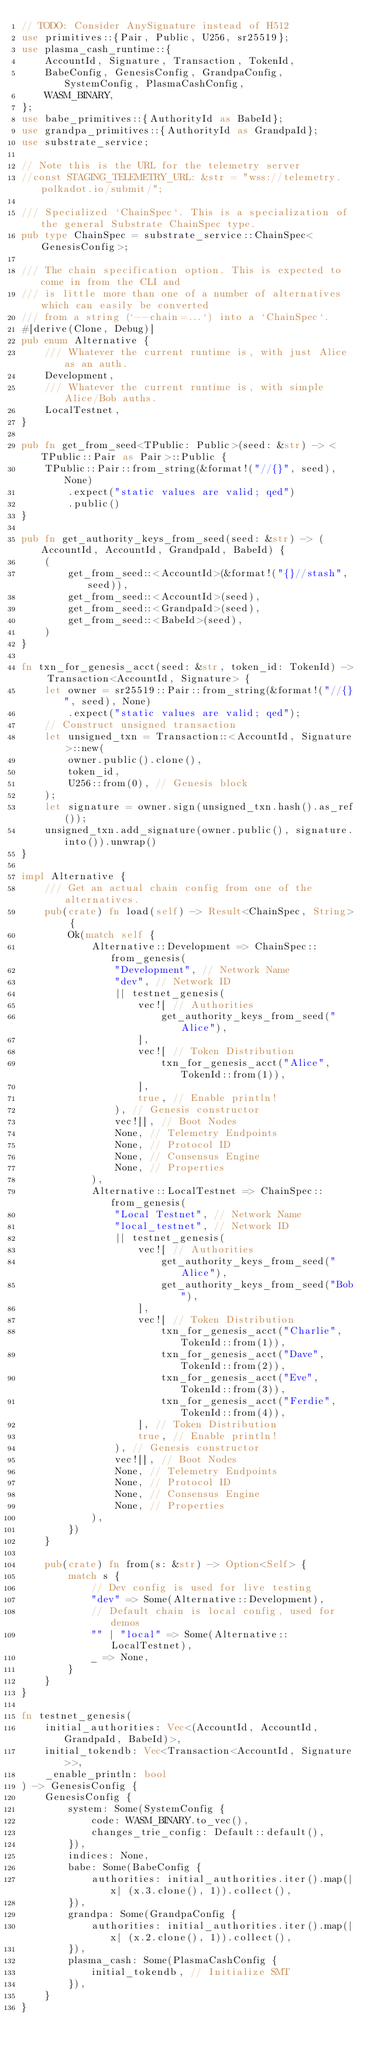Convert code to text. <code><loc_0><loc_0><loc_500><loc_500><_Rust_>// TODO: Consider AnySignature instead of H512
use primitives::{Pair, Public, U256, sr25519};
use plasma_cash_runtime::{
    AccountId, Signature, Transaction, TokenId,
    BabeConfig, GenesisConfig, GrandpaConfig, SystemConfig, PlasmaCashConfig,
    WASM_BINARY,
};
use babe_primitives::{AuthorityId as BabeId};
use grandpa_primitives::{AuthorityId as GrandpaId};
use substrate_service;

// Note this is the URL for the telemetry server
//const STAGING_TELEMETRY_URL: &str = "wss://telemetry.polkadot.io/submit/";

/// Specialized `ChainSpec`. This is a specialization of the general Substrate ChainSpec type.
pub type ChainSpec = substrate_service::ChainSpec<GenesisConfig>;

/// The chain specification option. This is expected to come in from the CLI and
/// is little more than one of a number of alternatives which can easily be converted
/// from a string (`--chain=...`) into a `ChainSpec`.
#[derive(Clone, Debug)]
pub enum Alternative {
    /// Whatever the current runtime is, with just Alice as an auth.
    Development,
    /// Whatever the current runtime is, with simple Alice/Bob auths.
    LocalTestnet,
}

pub fn get_from_seed<TPublic: Public>(seed: &str) -> <TPublic::Pair as Pair>::Public {
    TPublic::Pair::from_string(&format!("//{}", seed), None)
        .expect("static values are valid; qed")
        .public()
}

pub fn get_authority_keys_from_seed(seed: &str) -> (AccountId, AccountId, GrandpaId, BabeId) {
    (
        get_from_seed::<AccountId>(&format!("{}//stash", seed)),
        get_from_seed::<AccountId>(seed),
        get_from_seed::<GrandpaId>(seed),
        get_from_seed::<BabeId>(seed),
    )
}

fn txn_for_genesis_acct(seed: &str, token_id: TokenId) -> Transaction<AccountId, Signature> {
    let owner = sr25519::Pair::from_string(&format!("//{}", seed), None)
        .expect("static values are valid; qed");
    // Construct unsigned transaction
    let unsigned_txn = Transaction::<AccountId, Signature>::new(
        owner.public().clone(),
        token_id,
        U256::from(0), // Genesis block
    );
    let signature = owner.sign(unsigned_txn.hash().as_ref());
    unsigned_txn.add_signature(owner.public(), signature.into()).unwrap()
}

impl Alternative {
    /// Get an actual chain config from one of the alternatives.
    pub(crate) fn load(self) -> Result<ChainSpec, String> {
        Ok(match self {
            Alternative::Development => ChainSpec::from_genesis(
                "Development", // Network Name
                "dev", // Network ID
                || testnet_genesis(
                    vec![ // Authorities
                        get_authority_keys_from_seed("Alice"),
                    ],
                    vec![ // Token Distribution
                        txn_for_genesis_acct("Alice", TokenId::from(1)),
                    ],
                    true, // Enable println!
                ), // Genesis constructor
                vec![], // Boot Nodes
                None, // Telemetry Endpoints
                None, // Protocol ID
                None, // Consensus Engine
                None, // Properties
            ),
            Alternative::LocalTestnet => ChainSpec::from_genesis(
                "Local Testnet", // Network Name
                "local_testnet", // Network ID
                || testnet_genesis(
                    vec![ // Authorities
                        get_authority_keys_from_seed("Alice"),
                        get_authority_keys_from_seed("Bob"),
                    ],
                    vec![ // Token Distribution
                        txn_for_genesis_acct("Charlie", TokenId::from(1)),
                        txn_for_genesis_acct("Dave",    TokenId::from(2)),
                        txn_for_genesis_acct("Eve",     TokenId::from(3)),
                        txn_for_genesis_acct("Ferdie",  TokenId::from(4)),
                    ], // Token Distribution
                    true, // Enable println!
                ), // Genesis constructor
                vec![], // Boot Nodes
                None, // Telemetry Endpoints
                None, // Protocol ID
                None, // Consensus Engine
                None, // Properties
            ),
        })
    }

    pub(crate) fn from(s: &str) -> Option<Self> {
        match s {
            // Dev config is used for live testing
            "dev" => Some(Alternative::Development),
            // Default chain is local config, used for demos
            "" | "local" => Some(Alternative::LocalTestnet),
            _ => None,
        }
    }
}

fn testnet_genesis(
    initial_authorities: Vec<(AccountId, AccountId, GrandpaId, BabeId)>,
    initial_tokendb: Vec<Transaction<AccountId, Signature>>,
    _enable_println: bool
) -> GenesisConfig {
    GenesisConfig {
        system: Some(SystemConfig {
            code: WASM_BINARY.to_vec(),
            changes_trie_config: Default::default(),
        }),
        indices: None,
        babe: Some(BabeConfig {
            authorities: initial_authorities.iter().map(|x| (x.3.clone(), 1)).collect(),
        }),
        grandpa: Some(GrandpaConfig {
            authorities: initial_authorities.iter().map(|x| (x.2.clone(), 1)).collect(),
        }),
        plasma_cash: Some(PlasmaCashConfig {
            initial_tokendb, // Initialize SMT
        }),
    }
}
</code> 